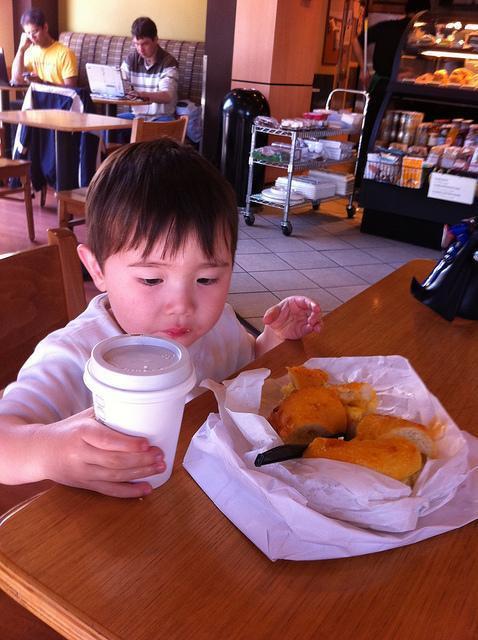How many laptops can be seen?
Give a very brief answer. 2. How many people can you see?
Give a very brief answer. 3. How many dining tables are there?
Give a very brief answer. 2. How many sandwiches are there?
Give a very brief answer. 2. How many chairs are in the photo?
Give a very brief answer. 2. 